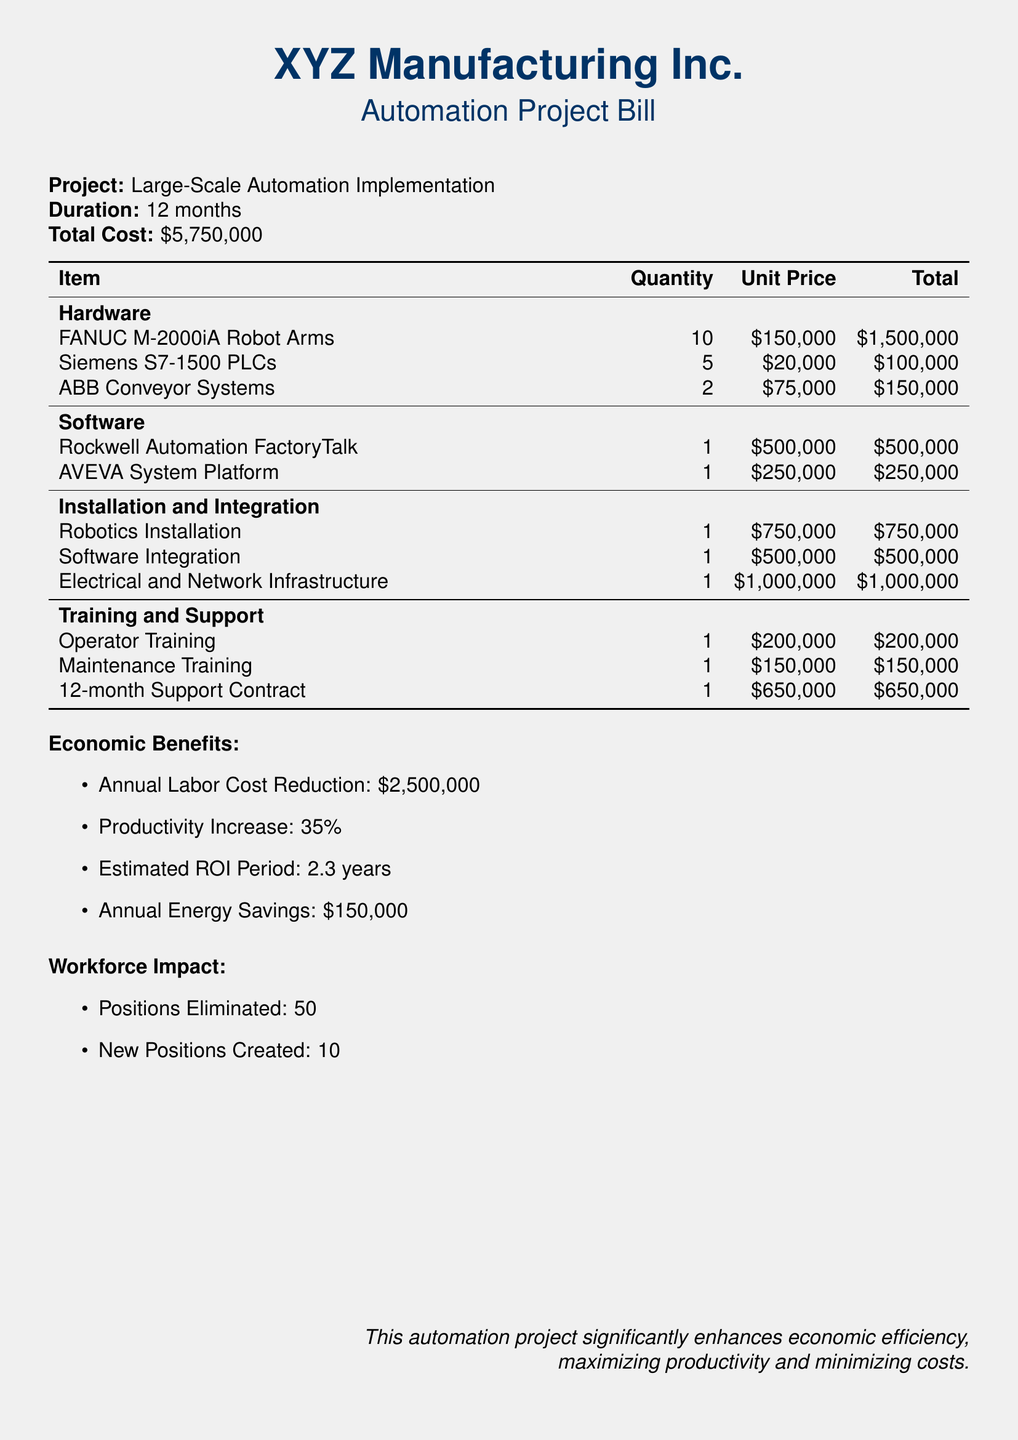What is the total cost of the project? The total cost is provided at the beginning of the document as the overall financial figure for the project.
Answer: $5,750,000 How many robot arms are included in the project? The quantity of FANUC M-2000iA Robot Arms is specified in the hardware section of the bill.
Answer: 10 What is the annual labor cost reduction expected from this project? The document explicitly mentions the expected annual reduction in labor costs as a benefit of the automation project.
Answer: $2,500,000 What is the productivity increase percentage from implementing this automation? The document states the percentage increase in productivity as one of the economic benefits of the automation project.
Answer: 35% What is the anticipated ROI period? The estimated return on investment period is clearly outlined in the economic benefits section of the document.
Answer: 2.3 years How many positions are eliminated due to this project? The workforce impact section indicates the number of positions that will be eliminated as a result of the automation.
Answer: 50 What is the unit price of the Rockwell Automation FactoryTalk software? The unit price for Rockwell Automation FactoryTalk is listed in the software section of the bill.
Answer: $500,000 What does the document state about the 12-month support contract cost? The cost for the 12-month support contract is explicitly mentioned under the training and support section of the bill.
Answer: $650,000 How many new positions are created due to this project? The document notes the number of new positions created as a result of the automation project in the workforce impact section.
Answer: 10 